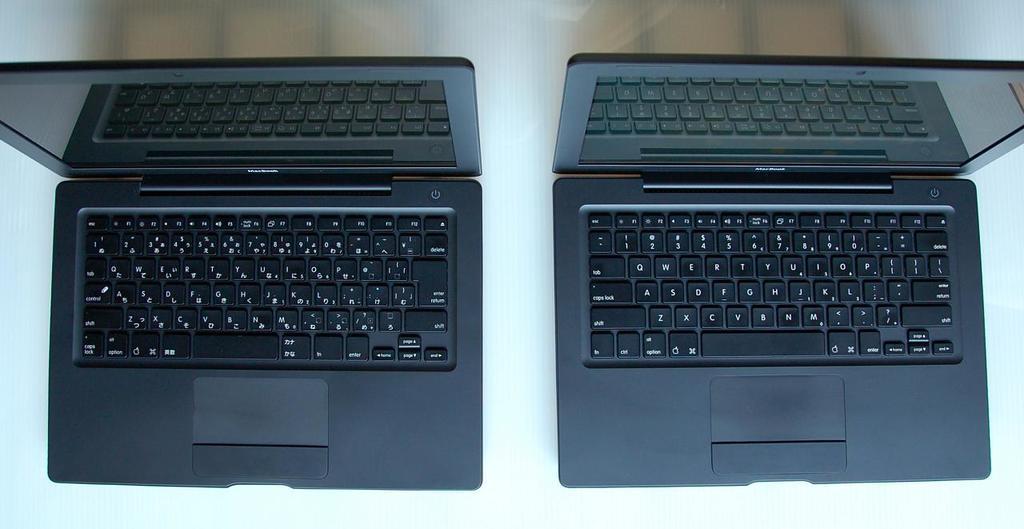In one or two sentences, can you explain what this image depicts? In this picture we can see two laptops on the platform. 